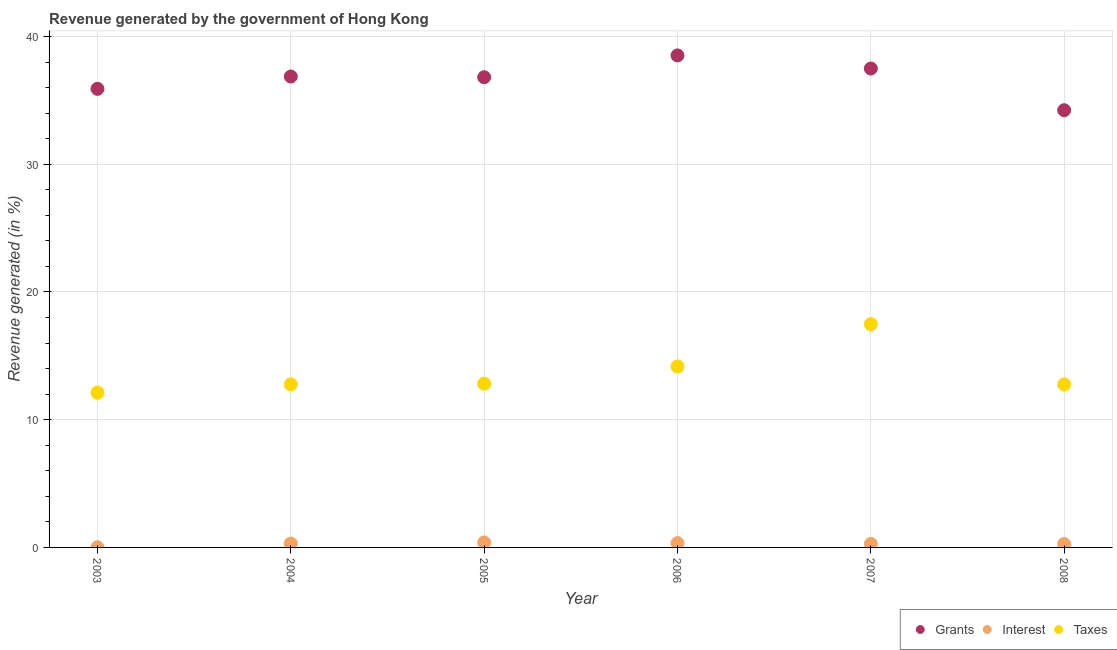What is the percentage of revenue generated by interest in 2006?
Keep it short and to the point. 0.34. Across all years, what is the maximum percentage of revenue generated by grants?
Your answer should be compact. 38.52. Across all years, what is the minimum percentage of revenue generated by taxes?
Your answer should be compact. 12.12. In which year was the percentage of revenue generated by grants maximum?
Your answer should be compact. 2006. In which year was the percentage of revenue generated by taxes minimum?
Your answer should be very brief. 2003. What is the total percentage of revenue generated by taxes in the graph?
Provide a succinct answer. 82.14. What is the difference between the percentage of revenue generated by interest in 2003 and that in 2006?
Ensure brevity in your answer.  -0.32. What is the difference between the percentage of revenue generated by grants in 2006 and the percentage of revenue generated by interest in 2004?
Your answer should be compact. 38.22. What is the average percentage of revenue generated by taxes per year?
Make the answer very short. 13.69. In the year 2005, what is the difference between the percentage of revenue generated by interest and percentage of revenue generated by grants?
Make the answer very short. -36.43. What is the ratio of the percentage of revenue generated by taxes in 2005 to that in 2008?
Offer a very short reply. 1. Is the percentage of revenue generated by interest in 2003 less than that in 2004?
Provide a succinct answer. Yes. Is the difference between the percentage of revenue generated by grants in 2006 and 2008 greater than the difference between the percentage of revenue generated by taxes in 2006 and 2008?
Offer a terse response. Yes. What is the difference between the highest and the second highest percentage of revenue generated by interest?
Your answer should be compact. 0.05. What is the difference between the highest and the lowest percentage of revenue generated by grants?
Your answer should be compact. 4.29. In how many years, is the percentage of revenue generated by grants greater than the average percentage of revenue generated by grants taken over all years?
Your answer should be very brief. 4. Is the sum of the percentage of revenue generated by grants in 2007 and 2008 greater than the maximum percentage of revenue generated by taxes across all years?
Provide a succinct answer. Yes. Does the percentage of revenue generated by taxes monotonically increase over the years?
Your answer should be compact. No. What is the difference between two consecutive major ticks on the Y-axis?
Your answer should be compact. 10. Does the graph contain grids?
Make the answer very short. Yes. How many legend labels are there?
Your response must be concise. 3. How are the legend labels stacked?
Provide a short and direct response. Horizontal. What is the title of the graph?
Provide a short and direct response. Revenue generated by the government of Hong Kong. What is the label or title of the X-axis?
Your answer should be compact. Year. What is the label or title of the Y-axis?
Ensure brevity in your answer.  Revenue generated (in %). What is the Revenue generated (in %) of Grants in 2003?
Offer a very short reply. 35.91. What is the Revenue generated (in %) of Interest in 2003?
Ensure brevity in your answer.  0.02. What is the Revenue generated (in %) in Taxes in 2003?
Make the answer very short. 12.12. What is the Revenue generated (in %) in Grants in 2004?
Make the answer very short. 36.87. What is the Revenue generated (in %) of Interest in 2004?
Your response must be concise. 0.31. What is the Revenue generated (in %) of Taxes in 2004?
Keep it short and to the point. 12.77. What is the Revenue generated (in %) of Grants in 2005?
Offer a terse response. 36.82. What is the Revenue generated (in %) of Interest in 2005?
Ensure brevity in your answer.  0.39. What is the Revenue generated (in %) in Taxes in 2005?
Make the answer very short. 12.82. What is the Revenue generated (in %) in Grants in 2006?
Give a very brief answer. 38.52. What is the Revenue generated (in %) of Interest in 2006?
Your response must be concise. 0.34. What is the Revenue generated (in %) of Taxes in 2006?
Provide a succinct answer. 14.17. What is the Revenue generated (in %) of Grants in 2007?
Your answer should be compact. 37.5. What is the Revenue generated (in %) of Interest in 2007?
Your answer should be very brief. 0.28. What is the Revenue generated (in %) of Taxes in 2007?
Your answer should be very brief. 17.49. What is the Revenue generated (in %) of Grants in 2008?
Offer a terse response. 34.23. What is the Revenue generated (in %) of Interest in 2008?
Ensure brevity in your answer.  0.27. What is the Revenue generated (in %) in Taxes in 2008?
Offer a very short reply. 12.77. Across all years, what is the maximum Revenue generated (in %) in Grants?
Your response must be concise. 38.52. Across all years, what is the maximum Revenue generated (in %) of Interest?
Provide a succinct answer. 0.39. Across all years, what is the maximum Revenue generated (in %) in Taxes?
Provide a short and direct response. 17.49. Across all years, what is the minimum Revenue generated (in %) of Grants?
Offer a terse response. 34.23. Across all years, what is the minimum Revenue generated (in %) of Interest?
Keep it short and to the point. 0.02. Across all years, what is the minimum Revenue generated (in %) in Taxes?
Your answer should be very brief. 12.12. What is the total Revenue generated (in %) of Grants in the graph?
Provide a short and direct response. 219.86. What is the total Revenue generated (in %) in Interest in the graph?
Give a very brief answer. 1.6. What is the total Revenue generated (in %) of Taxes in the graph?
Your answer should be very brief. 82.14. What is the difference between the Revenue generated (in %) of Grants in 2003 and that in 2004?
Offer a very short reply. -0.97. What is the difference between the Revenue generated (in %) in Interest in 2003 and that in 2004?
Your answer should be very brief. -0.29. What is the difference between the Revenue generated (in %) in Taxes in 2003 and that in 2004?
Provide a succinct answer. -0.65. What is the difference between the Revenue generated (in %) in Grants in 2003 and that in 2005?
Your response must be concise. -0.91. What is the difference between the Revenue generated (in %) of Interest in 2003 and that in 2005?
Provide a short and direct response. -0.37. What is the difference between the Revenue generated (in %) in Taxes in 2003 and that in 2005?
Your response must be concise. -0.71. What is the difference between the Revenue generated (in %) of Grants in 2003 and that in 2006?
Provide a succinct answer. -2.62. What is the difference between the Revenue generated (in %) in Interest in 2003 and that in 2006?
Provide a short and direct response. -0.32. What is the difference between the Revenue generated (in %) of Taxes in 2003 and that in 2006?
Your response must be concise. -2.06. What is the difference between the Revenue generated (in %) in Grants in 2003 and that in 2007?
Offer a very short reply. -1.59. What is the difference between the Revenue generated (in %) of Interest in 2003 and that in 2007?
Offer a very short reply. -0.26. What is the difference between the Revenue generated (in %) of Taxes in 2003 and that in 2007?
Your answer should be very brief. -5.37. What is the difference between the Revenue generated (in %) in Grants in 2003 and that in 2008?
Provide a short and direct response. 1.67. What is the difference between the Revenue generated (in %) in Interest in 2003 and that in 2008?
Keep it short and to the point. -0.26. What is the difference between the Revenue generated (in %) of Taxes in 2003 and that in 2008?
Ensure brevity in your answer.  -0.65. What is the difference between the Revenue generated (in %) in Grants in 2004 and that in 2005?
Offer a terse response. 0.06. What is the difference between the Revenue generated (in %) in Interest in 2004 and that in 2005?
Your answer should be very brief. -0.09. What is the difference between the Revenue generated (in %) in Taxes in 2004 and that in 2005?
Provide a short and direct response. -0.05. What is the difference between the Revenue generated (in %) of Grants in 2004 and that in 2006?
Your response must be concise. -1.65. What is the difference between the Revenue generated (in %) in Interest in 2004 and that in 2006?
Keep it short and to the point. -0.03. What is the difference between the Revenue generated (in %) of Taxes in 2004 and that in 2006?
Your response must be concise. -1.4. What is the difference between the Revenue generated (in %) of Grants in 2004 and that in 2007?
Provide a short and direct response. -0.63. What is the difference between the Revenue generated (in %) of Interest in 2004 and that in 2007?
Make the answer very short. 0.03. What is the difference between the Revenue generated (in %) in Taxes in 2004 and that in 2007?
Your response must be concise. -4.72. What is the difference between the Revenue generated (in %) of Grants in 2004 and that in 2008?
Keep it short and to the point. 2.64. What is the difference between the Revenue generated (in %) in Interest in 2004 and that in 2008?
Offer a very short reply. 0.03. What is the difference between the Revenue generated (in %) in Taxes in 2004 and that in 2008?
Provide a short and direct response. 0. What is the difference between the Revenue generated (in %) in Grants in 2005 and that in 2006?
Offer a terse response. -1.71. What is the difference between the Revenue generated (in %) of Interest in 2005 and that in 2006?
Your answer should be very brief. 0.05. What is the difference between the Revenue generated (in %) in Taxes in 2005 and that in 2006?
Your response must be concise. -1.35. What is the difference between the Revenue generated (in %) of Grants in 2005 and that in 2007?
Keep it short and to the point. -0.68. What is the difference between the Revenue generated (in %) in Interest in 2005 and that in 2007?
Your answer should be compact. 0.12. What is the difference between the Revenue generated (in %) of Taxes in 2005 and that in 2007?
Ensure brevity in your answer.  -4.66. What is the difference between the Revenue generated (in %) in Grants in 2005 and that in 2008?
Keep it short and to the point. 2.58. What is the difference between the Revenue generated (in %) of Interest in 2005 and that in 2008?
Make the answer very short. 0.12. What is the difference between the Revenue generated (in %) of Taxes in 2005 and that in 2008?
Make the answer very short. 0.06. What is the difference between the Revenue generated (in %) in Grants in 2006 and that in 2007?
Provide a short and direct response. 1.03. What is the difference between the Revenue generated (in %) of Interest in 2006 and that in 2007?
Provide a succinct answer. 0.06. What is the difference between the Revenue generated (in %) in Taxes in 2006 and that in 2007?
Your answer should be compact. -3.31. What is the difference between the Revenue generated (in %) of Grants in 2006 and that in 2008?
Keep it short and to the point. 4.29. What is the difference between the Revenue generated (in %) in Interest in 2006 and that in 2008?
Make the answer very short. 0.07. What is the difference between the Revenue generated (in %) of Taxes in 2006 and that in 2008?
Offer a terse response. 1.41. What is the difference between the Revenue generated (in %) of Grants in 2007 and that in 2008?
Offer a very short reply. 3.27. What is the difference between the Revenue generated (in %) in Interest in 2007 and that in 2008?
Make the answer very short. 0. What is the difference between the Revenue generated (in %) of Taxes in 2007 and that in 2008?
Provide a short and direct response. 4.72. What is the difference between the Revenue generated (in %) in Grants in 2003 and the Revenue generated (in %) in Interest in 2004?
Ensure brevity in your answer.  35.6. What is the difference between the Revenue generated (in %) in Grants in 2003 and the Revenue generated (in %) in Taxes in 2004?
Your response must be concise. 23.14. What is the difference between the Revenue generated (in %) of Interest in 2003 and the Revenue generated (in %) of Taxes in 2004?
Make the answer very short. -12.75. What is the difference between the Revenue generated (in %) in Grants in 2003 and the Revenue generated (in %) in Interest in 2005?
Make the answer very short. 35.52. What is the difference between the Revenue generated (in %) of Grants in 2003 and the Revenue generated (in %) of Taxes in 2005?
Offer a terse response. 23.08. What is the difference between the Revenue generated (in %) of Interest in 2003 and the Revenue generated (in %) of Taxes in 2005?
Keep it short and to the point. -12.81. What is the difference between the Revenue generated (in %) of Grants in 2003 and the Revenue generated (in %) of Interest in 2006?
Your answer should be compact. 35.57. What is the difference between the Revenue generated (in %) in Grants in 2003 and the Revenue generated (in %) in Taxes in 2006?
Offer a terse response. 21.73. What is the difference between the Revenue generated (in %) of Interest in 2003 and the Revenue generated (in %) of Taxes in 2006?
Your response must be concise. -14.16. What is the difference between the Revenue generated (in %) in Grants in 2003 and the Revenue generated (in %) in Interest in 2007?
Offer a terse response. 35.63. What is the difference between the Revenue generated (in %) of Grants in 2003 and the Revenue generated (in %) of Taxes in 2007?
Your response must be concise. 18.42. What is the difference between the Revenue generated (in %) in Interest in 2003 and the Revenue generated (in %) in Taxes in 2007?
Offer a very short reply. -17.47. What is the difference between the Revenue generated (in %) of Grants in 2003 and the Revenue generated (in %) of Interest in 2008?
Make the answer very short. 35.63. What is the difference between the Revenue generated (in %) of Grants in 2003 and the Revenue generated (in %) of Taxes in 2008?
Ensure brevity in your answer.  23.14. What is the difference between the Revenue generated (in %) in Interest in 2003 and the Revenue generated (in %) in Taxes in 2008?
Provide a succinct answer. -12.75. What is the difference between the Revenue generated (in %) of Grants in 2004 and the Revenue generated (in %) of Interest in 2005?
Make the answer very short. 36.48. What is the difference between the Revenue generated (in %) of Grants in 2004 and the Revenue generated (in %) of Taxes in 2005?
Provide a succinct answer. 24.05. What is the difference between the Revenue generated (in %) in Interest in 2004 and the Revenue generated (in %) in Taxes in 2005?
Offer a very short reply. -12.52. What is the difference between the Revenue generated (in %) in Grants in 2004 and the Revenue generated (in %) in Interest in 2006?
Keep it short and to the point. 36.53. What is the difference between the Revenue generated (in %) of Grants in 2004 and the Revenue generated (in %) of Taxes in 2006?
Offer a very short reply. 22.7. What is the difference between the Revenue generated (in %) in Interest in 2004 and the Revenue generated (in %) in Taxes in 2006?
Provide a succinct answer. -13.87. What is the difference between the Revenue generated (in %) of Grants in 2004 and the Revenue generated (in %) of Interest in 2007?
Keep it short and to the point. 36.6. What is the difference between the Revenue generated (in %) in Grants in 2004 and the Revenue generated (in %) in Taxes in 2007?
Provide a succinct answer. 19.39. What is the difference between the Revenue generated (in %) in Interest in 2004 and the Revenue generated (in %) in Taxes in 2007?
Your answer should be very brief. -17.18. What is the difference between the Revenue generated (in %) in Grants in 2004 and the Revenue generated (in %) in Interest in 2008?
Give a very brief answer. 36.6. What is the difference between the Revenue generated (in %) in Grants in 2004 and the Revenue generated (in %) in Taxes in 2008?
Ensure brevity in your answer.  24.11. What is the difference between the Revenue generated (in %) of Interest in 2004 and the Revenue generated (in %) of Taxes in 2008?
Make the answer very short. -12.46. What is the difference between the Revenue generated (in %) in Grants in 2005 and the Revenue generated (in %) in Interest in 2006?
Offer a very short reply. 36.48. What is the difference between the Revenue generated (in %) in Grants in 2005 and the Revenue generated (in %) in Taxes in 2006?
Provide a succinct answer. 22.64. What is the difference between the Revenue generated (in %) of Interest in 2005 and the Revenue generated (in %) of Taxes in 2006?
Provide a short and direct response. -13.78. What is the difference between the Revenue generated (in %) in Grants in 2005 and the Revenue generated (in %) in Interest in 2007?
Your answer should be compact. 36.54. What is the difference between the Revenue generated (in %) in Grants in 2005 and the Revenue generated (in %) in Taxes in 2007?
Offer a terse response. 19.33. What is the difference between the Revenue generated (in %) in Interest in 2005 and the Revenue generated (in %) in Taxes in 2007?
Make the answer very short. -17.1. What is the difference between the Revenue generated (in %) in Grants in 2005 and the Revenue generated (in %) in Interest in 2008?
Your answer should be compact. 36.54. What is the difference between the Revenue generated (in %) in Grants in 2005 and the Revenue generated (in %) in Taxes in 2008?
Your answer should be compact. 24.05. What is the difference between the Revenue generated (in %) of Interest in 2005 and the Revenue generated (in %) of Taxes in 2008?
Keep it short and to the point. -12.37. What is the difference between the Revenue generated (in %) in Grants in 2006 and the Revenue generated (in %) in Interest in 2007?
Your answer should be compact. 38.25. What is the difference between the Revenue generated (in %) in Grants in 2006 and the Revenue generated (in %) in Taxes in 2007?
Give a very brief answer. 21.04. What is the difference between the Revenue generated (in %) in Interest in 2006 and the Revenue generated (in %) in Taxes in 2007?
Your response must be concise. -17.15. What is the difference between the Revenue generated (in %) in Grants in 2006 and the Revenue generated (in %) in Interest in 2008?
Give a very brief answer. 38.25. What is the difference between the Revenue generated (in %) of Grants in 2006 and the Revenue generated (in %) of Taxes in 2008?
Provide a succinct answer. 25.76. What is the difference between the Revenue generated (in %) of Interest in 2006 and the Revenue generated (in %) of Taxes in 2008?
Keep it short and to the point. -12.43. What is the difference between the Revenue generated (in %) of Grants in 2007 and the Revenue generated (in %) of Interest in 2008?
Provide a short and direct response. 37.23. What is the difference between the Revenue generated (in %) of Grants in 2007 and the Revenue generated (in %) of Taxes in 2008?
Give a very brief answer. 24.73. What is the difference between the Revenue generated (in %) in Interest in 2007 and the Revenue generated (in %) in Taxes in 2008?
Your answer should be very brief. -12.49. What is the average Revenue generated (in %) in Grants per year?
Offer a very short reply. 36.64. What is the average Revenue generated (in %) of Interest per year?
Give a very brief answer. 0.27. What is the average Revenue generated (in %) of Taxes per year?
Your answer should be very brief. 13.69. In the year 2003, what is the difference between the Revenue generated (in %) of Grants and Revenue generated (in %) of Interest?
Provide a short and direct response. 35.89. In the year 2003, what is the difference between the Revenue generated (in %) of Grants and Revenue generated (in %) of Taxes?
Provide a short and direct response. 23.79. In the year 2003, what is the difference between the Revenue generated (in %) of Interest and Revenue generated (in %) of Taxes?
Offer a very short reply. -12.1. In the year 2004, what is the difference between the Revenue generated (in %) in Grants and Revenue generated (in %) in Interest?
Make the answer very short. 36.57. In the year 2004, what is the difference between the Revenue generated (in %) of Grants and Revenue generated (in %) of Taxes?
Offer a very short reply. 24.1. In the year 2004, what is the difference between the Revenue generated (in %) in Interest and Revenue generated (in %) in Taxes?
Offer a terse response. -12.46. In the year 2005, what is the difference between the Revenue generated (in %) of Grants and Revenue generated (in %) of Interest?
Your answer should be very brief. 36.43. In the year 2005, what is the difference between the Revenue generated (in %) in Grants and Revenue generated (in %) in Taxes?
Offer a very short reply. 23.99. In the year 2005, what is the difference between the Revenue generated (in %) in Interest and Revenue generated (in %) in Taxes?
Your answer should be very brief. -12.43. In the year 2006, what is the difference between the Revenue generated (in %) of Grants and Revenue generated (in %) of Interest?
Offer a terse response. 38.18. In the year 2006, what is the difference between the Revenue generated (in %) in Grants and Revenue generated (in %) in Taxes?
Make the answer very short. 24.35. In the year 2006, what is the difference between the Revenue generated (in %) of Interest and Revenue generated (in %) of Taxes?
Your response must be concise. -13.83. In the year 2007, what is the difference between the Revenue generated (in %) in Grants and Revenue generated (in %) in Interest?
Keep it short and to the point. 37.22. In the year 2007, what is the difference between the Revenue generated (in %) of Grants and Revenue generated (in %) of Taxes?
Provide a succinct answer. 20.01. In the year 2007, what is the difference between the Revenue generated (in %) of Interest and Revenue generated (in %) of Taxes?
Ensure brevity in your answer.  -17.21. In the year 2008, what is the difference between the Revenue generated (in %) in Grants and Revenue generated (in %) in Interest?
Give a very brief answer. 33.96. In the year 2008, what is the difference between the Revenue generated (in %) of Grants and Revenue generated (in %) of Taxes?
Your answer should be very brief. 21.47. In the year 2008, what is the difference between the Revenue generated (in %) of Interest and Revenue generated (in %) of Taxes?
Offer a very short reply. -12.49. What is the ratio of the Revenue generated (in %) of Grants in 2003 to that in 2004?
Provide a succinct answer. 0.97. What is the ratio of the Revenue generated (in %) in Interest in 2003 to that in 2004?
Your response must be concise. 0.06. What is the ratio of the Revenue generated (in %) in Taxes in 2003 to that in 2004?
Ensure brevity in your answer.  0.95. What is the ratio of the Revenue generated (in %) in Grants in 2003 to that in 2005?
Ensure brevity in your answer.  0.98. What is the ratio of the Revenue generated (in %) in Interest in 2003 to that in 2005?
Your response must be concise. 0.04. What is the ratio of the Revenue generated (in %) in Taxes in 2003 to that in 2005?
Offer a very short reply. 0.94. What is the ratio of the Revenue generated (in %) of Grants in 2003 to that in 2006?
Your response must be concise. 0.93. What is the ratio of the Revenue generated (in %) in Interest in 2003 to that in 2006?
Make the answer very short. 0.05. What is the ratio of the Revenue generated (in %) of Taxes in 2003 to that in 2006?
Your response must be concise. 0.85. What is the ratio of the Revenue generated (in %) in Grants in 2003 to that in 2007?
Ensure brevity in your answer.  0.96. What is the ratio of the Revenue generated (in %) in Interest in 2003 to that in 2007?
Provide a short and direct response. 0.06. What is the ratio of the Revenue generated (in %) in Taxes in 2003 to that in 2007?
Keep it short and to the point. 0.69. What is the ratio of the Revenue generated (in %) in Grants in 2003 to that in 2008?
Ensure brevity in your answer.  1.05. What is the ratio of the Revenue generated (in %) of Interest in 2003 to that in 2008?
Provide a succinct answer. 0.06. What is the ratio of the Revenue generated (in %) in Taxes in 2003 to that in 2008?
Offer a very short reply. 0.95. What is the ratio of the Revenue generated (in %) of Grants in 2004 to that in 2005?
Your response must be concise. 1. What is the ratio of the Revenue generated (in %) in Interest in 2004 to that in 2005?
Your answer should be very brief. 0.78. What is the ratio of the Revenue generated (in %) in Taxes in 2004 to that in 2005?
Ensure brevity in your answer.  1. What is the ratio of the Revenue generated (in %) in Grants in 2004 to that in 2006?
Keep it short and to the point. 0.96. What is the ratio of the Revenue generated (in %) in Interest in 2004 to that in 2006?
Offer a terse response. 0.9. What is the ratio of the Revenue generated (in %) of Taxes in 2004 to that in 2006?
Provide a succinct answer. 0.9. What is the ratio of the Revenue generated (in %) in Grants in 2004 to that in 2007?
Provide a succinct answer. 0.98. What is the ratio of the Revenue generated (in %) of Interest in 2004 to that in 2007?
Make the answer very short. 1.11. What is the ratio of the Revenue generated (in %) in Taxes in 2004 to that in 2007?
Your answer should be compact. 0.73. What is the ratio of the Revenue generated (in %) in Grants in 2004 to that in 2008?
Offer a terse response. 1.08. What is the ratio of the Revenue generated (in %) of Interest in 2004 to that in 2008?
Your answer should be very brief. 1.12. What is the ratio of the Revenue generated (in %) of Taxes in 2004 to that in 2008?
Make the answer very short. 1. What is the ratio of the Revenue generated (in %) in Grants in 2005 to that in 2006?
Your response must be concise. 0.96. What is the ratio of the Revenue generated (in %) of Interest in 2005 to that in 2006?
Give a very brief answer. 1.15. What is the ratio of the Revenue generated (in %) in Taxes in 2005 to that in 2006?
Ensure brevity in your answer.  0.9. What is the ratio of the Revenue generated (in %) of Grants in 2005 to that in 2007?
Provide a short and direct response. 0.98. What is the ratio of the Revenue generated (in %) of Interest in 2005 to that in 2007?
Ensure brevity in your answer.  1.42. What is the ratio of the Revenue generated (in %) in Taxes in 2005 to that in 2007?
Your response must be concise. 0.73. What is the ratio of the Revenue generated (in %) in Grants in 2005 to that in 2008?
Keep it short and to the point. 1.08. What is the ratio of the Revenue generated (in %) of Interest in 2005 to that in 2008?
Keep it short and to the point. 1.43. What is the ratio of the Revenue generated (in %) in Taxes in 2005 to that in 2008?
Ensure brevity in your answer.  1. What is the ratio of the Revenue generated (in %) in Grants in 2006 to that in 2007?
Make the answer very short. 1.03. What is the ratio of the Revenue generated (in %) in Interest in 2006 to that in 2007?
Your answer should be compact. 1.23. What is the ratio of the Revenue generated (in %) of Taxes in 2006 to that in 2007?
Offer a very short reply. 0.81. What is the ratio of the Revenue generated (in %) in Grants in 2006 to that in 2008?
Your response must be concise. 1.13. What is the ratio of the Revenue generated (in %) of Interest in 2006 to that in 2008?
Offer a terse response. 1.25. What is the ratio of the Revenue generated (in %) in Taxes in 2006 to that in 2008?
Offer a very short reply. 1.11. What is the ratio of the Revenue generated (in %) of Grants in 2007 to that in 2008?
Your response must be concise. 1.1. What is the ratio of the Revenue generated (in %) of Interest in 2007 to that in 2008?
Keep it short and to the point. 1.01. What is the ratio of the Revenue generated (in %) in Taxes in 2007 to that in 2008?
Offer a very short reply. 1.37. What is the difference between the highest and the second highest Revenue generated (in %) of Grants?
Your answer should be very brief. 1.03. What is the difference between the highest and the second highest Revenue generated (in %) in Interest?
Your response must be concise. 0.05. What is the difference between the highest and the second highest Revenue generated (in %) of Taxes?
Provide a succinct answer. 3.31. What is the difference between the highest and the lowest Revenue generated (in %) in Grants?
Your answer should be very brief. 4.29. What is the difference between the highest and the lowest Revenue generated (in %) in Interest?
Your answer should be compact. 0.37. What is the difference between the highest and the lowest Revenue generated (in %) in Taxes?
Your response must be concise. 5.37. 